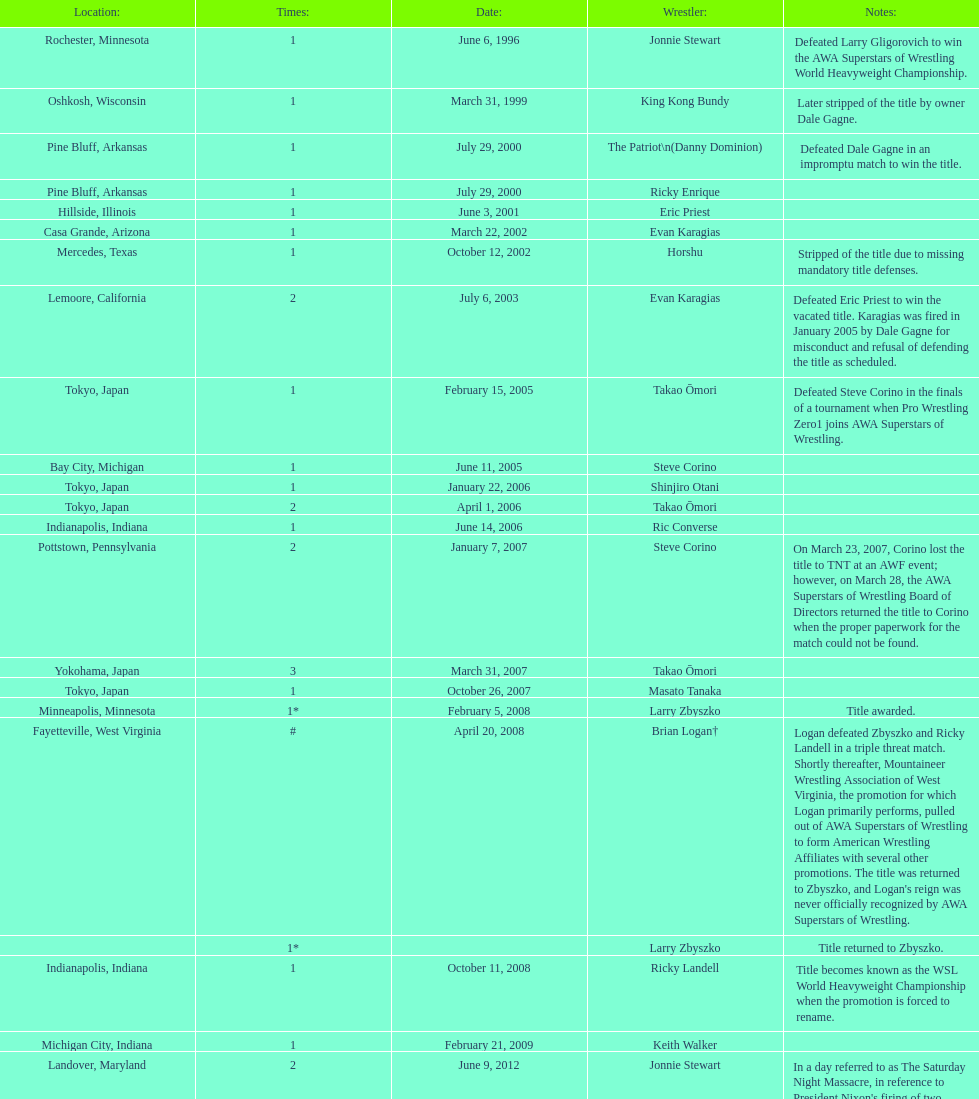When did steve corino win his first wsl title? June 11, 2005. 